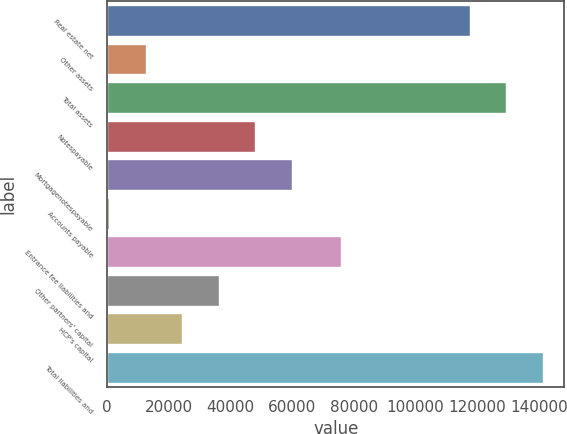<chart> <loc_0><loc_0><loc_500><loc_500><bar_chart><fcel>Real estate net<fcel>Other assets<fcel>Total assets<fcel>Notespayable<fcel>Mortgagenotespayable<fcel>Accounts payable<fcel>Entrance fee liabilities and<fcel>Other partners' capital<fcel>HCP's capital<fcel>Total liabilities and<nl><fcel>117557<fcel>12583.6<fcel>129374<fcel>48033.4<fcel>59850<fcel>767<fcel>75746<fcel>36216.8<fcel>24400.2<fcel>141190<nl></chart> 